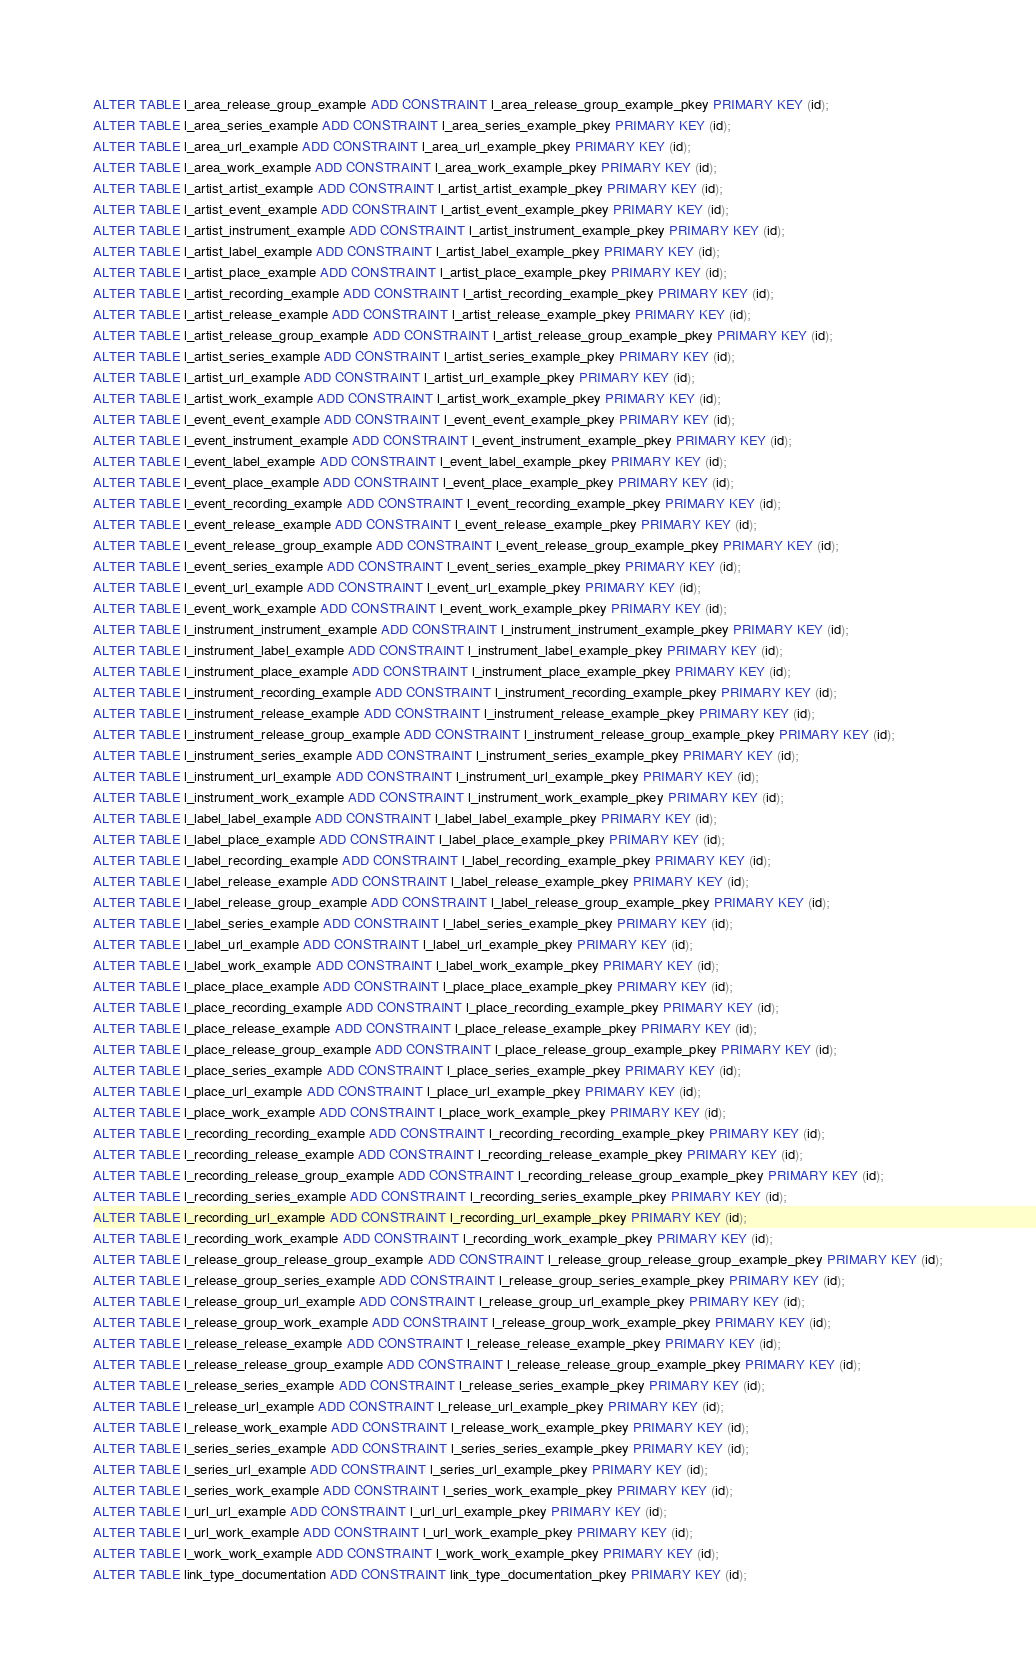Convert code to text. <code><loc_0><loc_0><loc_500><loc_500><_SQL_>ALTER TABLE l_area_release_group_example ADD CONSTRAINT l_area_release_group_example_pkey PRIMARY KEY (id);
ALTER TABLE l_area_series_example ADD CONSTRAINT l_area_series_example_pkey PRIMARY KEY (id);
ALTER TABLE l_area_url_example ADD CONSTRAINT l_area_url_example_pkey PRIMARY KEY (id);
ALTER TABLE l_area_work_example ADD CONSTRAINT l_area_work_example_pkey PRIMARY KEY (id);
ALTER TABLE l_artist_artist_example ADD CONSTRAINT l_artist_artist_example_pkey PRIMARY KEY (id);
ALTER TABLE l_artist_event_example ADD CONSTRAINT l_artist_event_example_pkey PRIMARY KEY (id);
ALTER TABLE l_artist_instrument_example ADD CONSTRAINT l_artist_instrument_example_pkey PRIMARY KEY (id);
ALTER TABLE l_artist_label_example ADD CONSTRAINT l_artist_label_example_pkey PRIMARY KEY (id);
ALTER TABLE l_artist_place_example ADD CONSTRAINT l_artist_place_example_pkey PRIMARY KEY (id);
ALTER TABLE l_artist_recording_example ADD CONSTRAINT l_artist_recording_example_pkey PRIMARY KEY (id);
ALTER TABLE l_artist_release_example ADD CONSTRAINT l_artist_release_example_pkey PRIMARY KEY (id);
ALTER TABLE l_artist_release_group_example ADD CONSTRAINT l_artist_release_group_example_pkey PRIMARY KEY (id);
ALTER TABLE l_artist_series_example ADD CONSTRAINT l_artist_series_example_pkey PRIMARY KEY (id);
ALTER TABLE l_artist_url_example ADD CONSTRAINT l_artist_url_example_pkey PRIMARY KEY (id);
ALTER TABLE l_artist_work_example ADD CONSTRAINT l_artist_work_example_pkey PRIMARY KEY (id);
ALTER TABLE l_event_event_example ADD CONSTRAINT l_event_event_example_pkey PRIMARY KEY (id);
ALTER TABLE l_event_instrument_example ADD CONSTRAINT l_event_instrument_example_pkey PRIMARY KEY (id);
ALTER TABLE l_event_label_example ADD CONSTRAINT l_event_label_example_pkey PRIMARY KEY (id);
ALTER TABLE l_event_place_example ADD CONSTRAINT l_event_place_example_pkey PRIMARY KEY (id);
ALTER TABLE l_event_recording_example ADD CONSTRAINT l_event_recording_example_pkey PRIMARY KEY (id);
ALTER TABLE l_event_release_example ADD CONSTRAINT l_event_release_example_pkey PRIMARY KEY (id);
ALTER TABLE l_event_release_group_example ADD CONSTRAINT l_event_release_group_example_pkey PRIMARY KEY (id);
ALTER TABLE l_event_series_example ADD CONSTRAINT l_event_series_example_pkey PRIMARY KEY (id);
ALTER TABLE l_event_url_example ADD CONSTRAINT l_event_url_example_pkey PRIMARY KEY (id);
ALTER TABLE l_event_work_example ADD CONSTRAINT l_event_work_example_pkey PRIMARY KEY (id);
ALTER TABLE l_instrument_instrument_example ADD CONSTRAINT l_instrument_instrument_example_pkey PRIMARY KEY (id);
ALTER TABLE l_instrument_label_example ADD CONSTRAINT l_instrument_label_example_pkey PRIMARY KEY (id);
ALTER TABLE l_instrument_place_example ADD CONSTRAINT l_instrument_place_example_pkey PRIMARY KEY (id);
ALTER TABLE l_instrument_recording_example ADD CONSTRAINT l_instrument_recording_example_pkey PRIMARY KEY (id);
ALTER TABLE l_instrument_release_example ADD CONSTRAINT l_instrument_release_example_pkey PRIMARY KEY (id);
ALTER TABLE l_instrument_release_group_example ADD CONSTRAINT l_instrument_release_group_example_pkey PRIMARY KEY (id);
ALTER TABLE l_instrument_series_example ADD CONSTRAINT l_instrument_series_example_pkey PRIMARY KEY (id);
ALTER TABLE l_instrument_url_example ADD CONSTRAINT l_instrument_url_example_pkey PRIMARY KEY (id);
ALTER TABLE l_instrument_work_example ADD CONSTRAINT l_instrument_work_example_pkey PRIMARY KEY (id);
ALTER TABLE l_label_label_example ADD CONSTRAINT l_label_label_example_pkey PRIMARY KEY (id);
ALTER TABLE l_label_place_example ADD CONSTRAINT l_label_place_example_pkey PRIMARY KEY (id);
ALTER TABLE l_label_recording_example ADD CONSTRAINT l_label_recording_example_pkey PRIMARY KEY (id);
ALTER TABLE l_label_release_example ADD CONSTRAINT l_label_release_example_pkey PRIMARY KEY (id);
ALTER TABLE l_label_release_group_example ADD CONSTRAINT l_label_release_group_example_pkey PRIMARY KEY (id);
ALTER TABLE l_label_series_example ADD CONSTRAINT l_label_series_example_pkey PRIMARY KEY (id);
ALTER TABLE l_label_url_example ADD CONSTRAINT l_label_url_example_pkey PRIMARY KEY (id);
ALTER TABLE l_label_work_example ADD CONSTRAINT l_label_work_example_pkey PRIMARY KEY (id);
ALTER TABLE l_place_place_example ADD CONSTRAINT l_place_place_example_pkey PRIMARY KEY (id);
ALTER TABLE l_place_recording_example ADD CONSTRAINT l_place_recording_example_pkey PRIMARY KEY (id);
ALTER TABLE l_place_release_example ADD CONSTRAINT l_place_release_example_pkey PRIMARY KEY (id);
ALTER TABLE l_place_release_group_example ADD CONSTRAINT l_place_release_group_example_pkey PRIMARY KEY (id);
ALTER TABLE l_place_series_example ADD CONSTRAINT l_place_series_example_pkey PRIMARY KEY (id);
ALTER TABLE l_place_url_example ADD CONSTRAINT l_place_url_example_pkey PRIMARY KEY (id);
ALTER TABLE l_place_work_example ADD CONSTRAINT l_place_work_example_pkey PRIMARY KEY (id);
ALTER TABLE l_recording_recording_example ADD CONSTRAINT l_recording_recording_example_pkey PRIMARY KEY (id);
ALTER TABLE l_recording_release_example ADD CONSTRAINT l_recording_release_example_pkey PRIMARY KEY (id);
ALTER TABLE l_recording_release_group_example ADD CONSTRAINT l_recording_release_group_example_pkey PRIMARY KEY (id);
ALTER TABLE l_recording_series_example ADD CONSTRAINT l_recording_series_example_pkey PRIMARY KEY (id);
ALTER TABLE l_recording_url_example ADD CONSTRAINT l_recording_url_example_pkey PRIMARY KEY (id);
ALTER TABLE l_recording_work_example ADD CONSTRAINT l_recording_work_example_pkey PRIMARY KEY (id);
ALTER TABLE l_release_group_release_group_example ADD CONSTRAINT l_release_group_release_group_example_pkey PRIMARY KEY (id);
ALTER TABLE l_release_group_series_example ADD CONSTRAINT l_release_group_series_example_pkey PRIMARY KEY (id);
ALTER TABLE l_release_group_url_example ADD CONSTRAINT l_release_group_url_example_pkey PRIMARY KEY (id);
ALTER TABLE l_release_group_work_example ADD CONSTRAINT l_release_group_work_example_pkey PRIMARY KEY (id);
ALTER TABLE l_release_release_example ADD CONSTRAINT l_release_release_example_pkey PRIMARY KEY (id);
ALTER TABLE l_release_release_group_example ADD CONSTRAINT l_release_release_group_example_pkey PRIMARY KEY (id);
ALTER TABLE l_release_series_example ADD CONSTRAINT l_release_series_example_pkey PRIMARY KEY (id);
ALTER TABLE l_release_url_example ADD CONSTRAINT l_release_url_example_pkey PRIMARY KEY (id);
ALTER TABLE l_release_work_example ADD CONSTRAINT l_release_work_example_pkey PRIMARY KEY (id);
ALTER TABLE l_series_series_example ADD CONSTRAINT l_series_series_example_pkey PRIMARY KEY (id);
ALTER TABLE l_series_url_example ADD CONSTRAINT l_series_url_example_pkey PRIMARY KEY (id);
ALTER TABLE l_series_work_example ADD CONSTRAINT l_series_work_example_pkey PRIMARY KEY (id);
ALTER TABLE l_url_url_example ADD CONSTRAINT l_url_url_example_pkey PRIMARY KEY (id);
ALTER TABLE l_url_work_example ADD CONSTRAINT l_url_work_example_pkey PRIMARY KEY (id);
ALTER TABLE l_work_work_example ADD CONSTRAINT l_work_work_example_pkey PRIMARY KEY (id);
ALTER TABLE link_type_documentation ADD CONSTRAINT link_type_documentation_pkey PRIMARY KEY (id);
</code> 